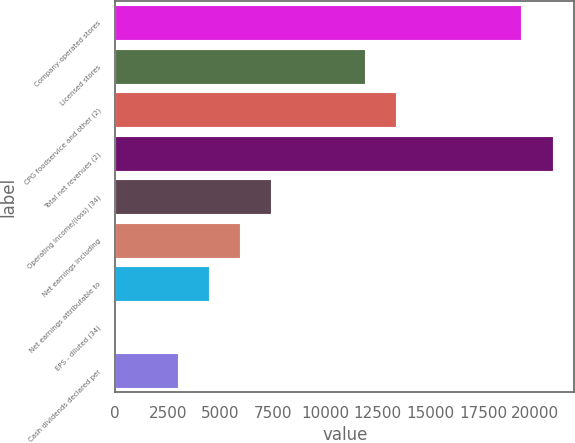Convert chart to OTSL. <chart><loc_0><loc_0><loc_500><loc_500><bar_chart><fcel>Company-operated stores<fcel>Licensed stores<fcel>CPG foodservice and other (2)<fcel>Total net revenues (2)<fcel>Operating income/(loss) (34)<fcel>Net earnings including<fcel>Net earnings attributable to<fcel>EPS - diluted (34)<fcel>Cash dividends declared per<nl><fcel>19326.8<fcel>11893.5<fcel>13380.1<fcel>20813.5<fcel>7433.41<fcel>5946.73<fcel>4460.05<fcel>0.01<fcel>2973.37<nl></chart> 